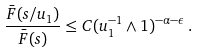<formula> <loc_0><loc_0><loc_500><loc_500>\frac { \bar { F } ( s / u _ { 1 } ) } { \bar { F } ( s ) } \leq C ( u _ { 1 } ^ { - 1 } \wedge 1 ) ^ { - \alpha - \epsilon } \, .</formula> 